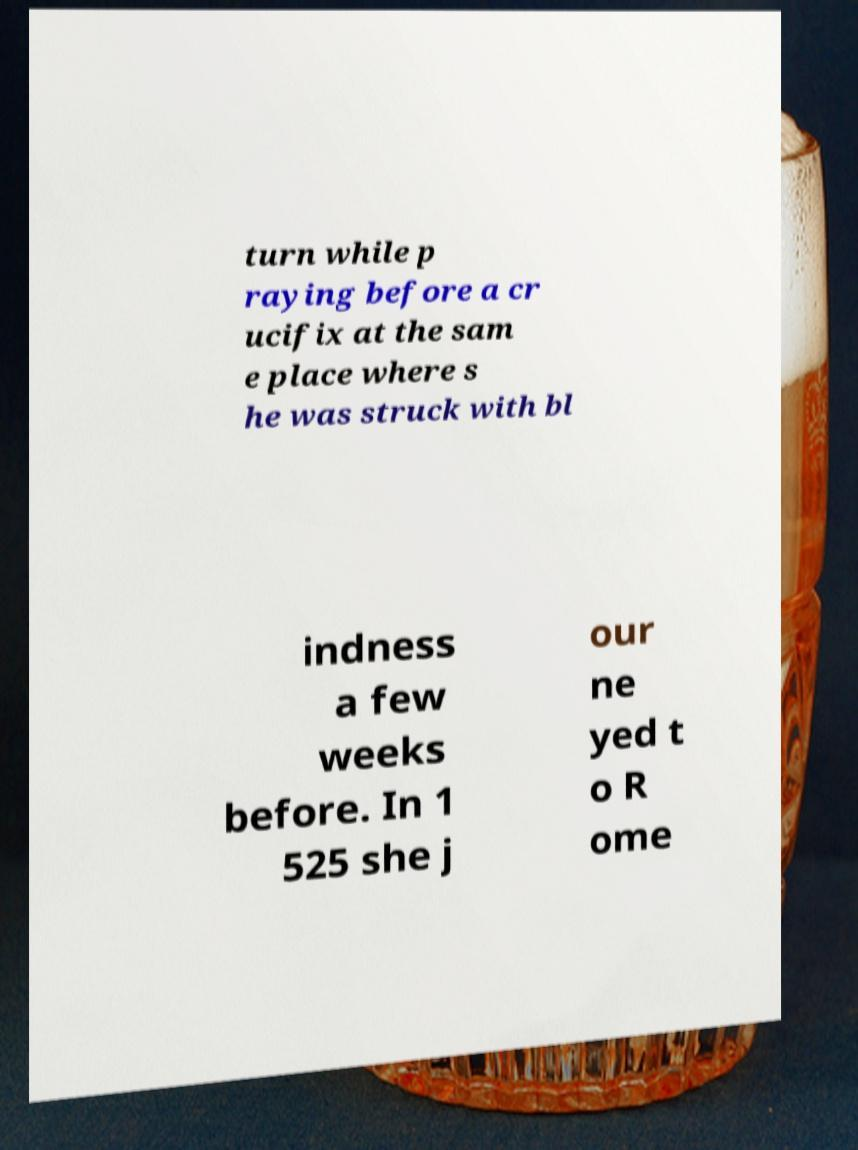Can you accurately transcribe the text from the provided image for me? turn while p raying before a cr ucifix at the sam e place where s he was struck with bl indness a few weeks before. In 1 525 she j our ne yed t o R ome 